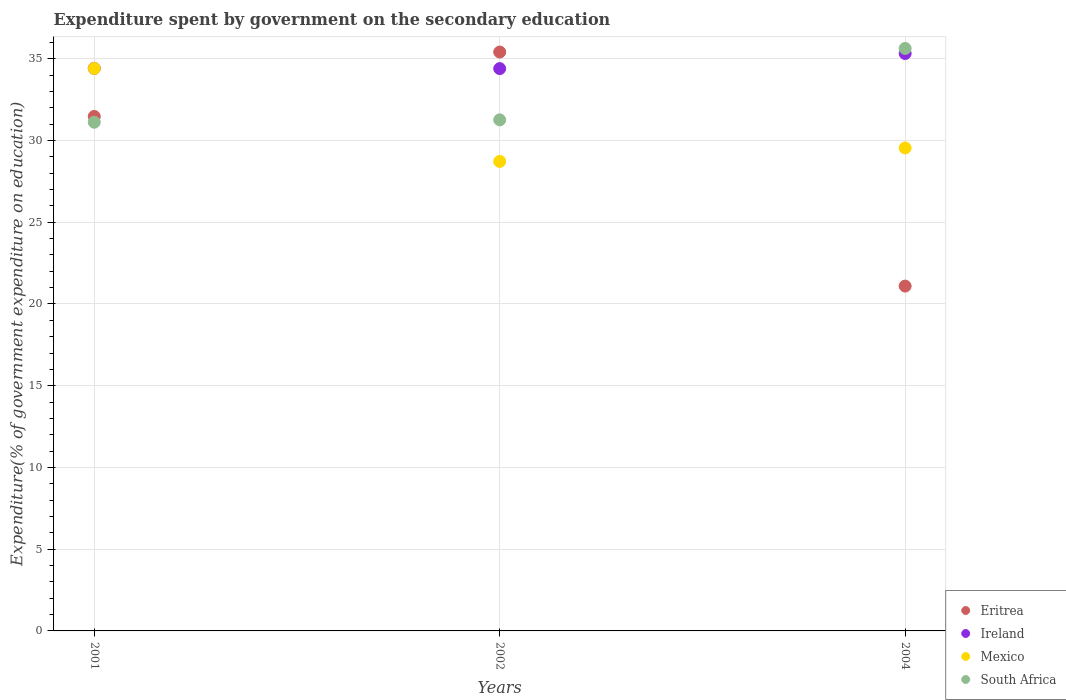What is the expenditure spent by government on the secondary education in Ireland in 2001?
Your answer should be compact. 34.41. Across all years, what is the maximum expenditure spent by government on the secondary education in Ireland?
Offer a very short reply. 35.32. Across all years, what is the minimum expenditure spent by government on the secondary education in Mexico?
Provide a short and direct response. 28.72. In which year was the expenditure spent by government on the secondary education in South Africa maximum?
Your answer should be compact. 2004. What is the total expenditure spent by government on the secondary education in Ireland in the graph?
Give a very brief answer. 104.13. What is the difference between the expenditure spent by government on the secondary education in South Africa in 2001 and that in 2004?
Keep it short and to the point. -4.51. What is the difference between the expenditure spent by government on the secondary education in Mexico in 2002 and the expenditure spent by government on the secondary education in South Africa in 2001?
Give a very brief answer. -2.4. What is the average expenditure spent by government on the secondary education in South Africa per year?
Keep it short and to the point. 32.67. In the year 2002, what is the difference between the expenditure spent by government on the secondary education in Ireland and expenditure spent by government on the secondary education in Eritrea?
Offer a terse response. -1.02. What is the ratio of the expenditure spent by government on the secondary education in Eritrea in 2001 to that in 2002?
Offer a terse response. 0.89. Is the difference between the expenditure spent by government on the secondary education in Ireland in 2001 and 2004 greater than the difference between the expenditure spent by government on the secondary education in Eritrea in 2001 and 2004?
Keep it short and to the point. No. What is the difference between the highest and the second highest expenditure spent by government on the secondary education in Eritrea?
Your answer should be compact. 3.94. What is the difference between the highest and the lowest expenditure spent by government on the secondary education in South Africa?
Offer a very short reply. 4.51. In how many years, is the expenditure spent by government on the secondary education in Mexico greater than the average expenditure spent by government on the secondary education in Mexico taken over all years?
Offer a terse response. 1. Is it the case that in every year, the sum of the expenditure spent by government on the secondary education in Ireland and expenditure spent by government on the secondary education in Eritrea  is greater than the sum of expenditure spent by government on the secondary education in Mexico and expenditure spent by government on the secondary education in South Africa?
Your answer should be compact. Yes. Is the expenditure spent by government on the secondary education in Mexico strictly greater than the expenditure spent by government on the secondary education in Ireland over the years?
Give a very brief answer. No. How many dotlines are there?
Your response must be concise. 4. How many years are there in the graph?
Provide a short and direct response. 3. Are the values on the major ticks of Y-axis written in scientific E-notation?
Make the answer very short. No. Where does the legend appear in the graph?
Your answer should be compact. Bottom right. How many legend labels are there?
Keep it short and to the point. 4. How are the legend labels stacked?
Your response must be concise. Vertical. What is the title of the graph?
Make the answer very short. Expenditure spent by government on the secondary education. Does "Aruba" appear as one of the legend labels in the graph?
Make the answer very short. No. What is the label or title of the X-axis?
Keep it short and to the point. Years. What is the label or title of the Y-axis?
Your answer should be compact. Expenditure(% of government expenditure on education). What is the Expenditure(% of government expenditure on education) in Eritrea in 2001?
Make the answer very short. 31.47. What is the Expenditure(% of government expenditure on education) in Ireland in 2001?
Your response must be concise. 34.41. What is the Expenditure(% of government expenditure on education) in Mexico in 2001?
Your response must be concise. 34.41. What is the Expenditure(% of government expenditure on education) in South Africa in 2001?
Your answer should be very brief. 31.12. What is the Expenditure(% of government expenditure on education) of Eritrea in 2002?
Keep it short and to the point. 35.41. What is the Expenditure(% of government expenditure on education) of Ireland in 2002?
Provide a succinct answer. 34.4. What is the Expenditure(% of government expenditure on education) of Mexico in 2002?
Ensure brevity in your answer.  28.72. What is the Expenditure(% of government expenditure on education) in South Africa in 2002?
Your response must be concise. 31.26. What is the Expenditure(% of government expenditure on education) of Eritrea in 2004?
Give a very brief answer. 21.09. What is the Expenditure(% of government expenditure on education) in Ireland in 2004?
Offer a terse response. 35.32. What is the Expenditure(% of government expenditure on education) in Mexico in 2004?
Offer a very short reply. 29.54. What is the Expenditure(% of government expenditure on education) of South Africa in 2004?
Your answer should be very brief. 35.63. Across all years, what is the maximum Expenditure(% of government expenditure on education) in Eritrea?
Your answer should be compact. 35.41. Across all years, what is the maximum Expenditure(% of government expenditure on education) in Ireland?
Your response must be concise. 35.32. Across all years, what is the maximum Expenditure(% of government expenditure on education) of Mexico?
Keep it short and to the point. 34.41. Across all years, what is the maximum Expenditure(% of government expenditure on education) in South Africa?
Offer a very short reply. 35.63. Across all years, what is the minimum Expenditure(% of government expenditure on education) of Eritrea?
Ensure brevity in your answer.  21.09. Across all years, what is the minimum Expenditure(% of government expenditure on education) of Ireland?
Make the answer very short. 34.4. Across all years, what is the minimum Expenditure(% of government expenditure on education) in Mexico?
Give a very brief answer. 28.72. Across all years, what is the minimum Expenditure(% of government expenditure on education) of South Africa?
Offer a very short reply. 31.12. What is the total Expenditure(% of government expenditure on education) in Eritrea in the graph?
Offer a terse response. 87.98. What is the total Expenditure(% of government expenditure on education) in Ireland in the graph?
Your answer should be very brief. 104.13. What is the total Expenditure(% of government expenditure on education) in Mexico in the graph?
Make the answer very short. 92.67. What is the total Expenditure(% of government expenditure on education) in South Africa in the graph?
Keep it short and to the point. 98.01. What is the difference between the Expenditure(% of government expenditure on education) of Eritrea in 2001 and that in 2002?
Offer a terse response. -3.94. What is the difference between the Expenditure(% of government expenditure on education) of Ireland in 2001 and that in 2002?
Provide a succinct answer. 0.02. What is the difference between the Expenditure(% of government expenditure on education) in Mexico in 2001 and that in 2002?
Your answer should be compact. 5.69. What is the difference between the Expenditure(% of government expenditure on education) in South Africa in 2001 and that in 2002?
Make the answer very short. -0.15. What is the difference between the Expenditure(% of government expenditure on education) in Eritrea in 2001 and that in 2004?
Provide a short and direct response. 10.38. What is the difference between the Expenditure(% of government expenditure on education) in Ireland in 2001 and that in 2004?
Offer a very short reply. -0.91. What is the difference between the Expenditure(% of government expenditure on education) of Mexico in 2001 and that in 2004?
Ensure brevity in your answer.  4.86. What is the difference between the Expenditure(% of government expenditure on education) of South Africa in 2001 and that in 2004?
Give a very brief answer. -4.51. What is the difference between the Expenditure(% of government expenditure on education) of Eritrea in 2002 and that in 2004?
Give a very brief answer. 14.32. What is the difference between the Expenditure(% of government expenditure on education) in Ireland in 2002 and that in 2004?
Your answer should be very brief. -0.92. What is the difference between the Expenditure(% of government expenditure on education) of Mexico in 2002 and that in 2004?
Offer a terse response. -0.82. What is the difference between the Expenditure(% of government expenditure on education) in South Africa in 2002 and that in 2004?
Provide a succinct answer. -4.37. What is the difference between the Expenditure(% of government expenditure on education) in Eritrea in 2001 and the Expenditure(% of government expenditure on education) in Ireland in 2002?
Offer a very short reply. -2.92. What is the difference between the Expenditure(% of government expenditure on education) of Eritrea in 2001 and the Expenditure(% of government expenditure on education) of Mexico in 2002?
Make the answer very short. 2.75. What is the difference between the Expenditure(% of government expenditure on education) of Eritrea in 2001 and the Expenditure(% of government expenditure on education) of South Africa in 2002?
Give a very brief answer. 0.21. What is the difference between the Expenditure(% of government expenditure on education) in Ireland in 2001 and the Expenditure(% of government expenditure on education) in Mexico in 2002?
Provide a succinct answer. 5.69. What is the difference between the Expenditure(% of government expenditure on education) of Ireland in 2001 and the Expenditure(% of government expenditure on education) of South Africa in 2002?
Offer a terse response. 3.15. What is the difference between the Expenditure(% of government expenditure on education) of Mexico in 2001 and the Expenditure(% of government expenditure on education) of South Africa in 2002?
Make the answer very short. 3.14. What is the difference between the Expenditure(% of government expenditure on education) of Eritrea in 2001 and the Expenditure(% of government expenditure on education) of Ireland in 2004?
Offer a terse response. -3.85. What is the difference between the Expenditure(% of government expenditure on education) in Eritrea in 2001 and the Expenditure(% of government expenditure on education) in Mexico in 2004?
Make the answer very short. 1.93. What is the difference between the Expenditure(% of government expenditure on education) of Eritrea in 2001 and the Expenditure(% of government expenditure on education) of South Africa in 2004?
Your answer should be compact. -4.16. What is the difference between the Expenditure(% of government expenditure on education) in Ireland in 2001 and the Expenditure(% of government expenditure on education) in Mexico in 2004?
Provide a succinct answer. 4.87. What is the difference between the Expenditure(% of government expenditure on education) in Ireland in 2001 and the Expenditure(% of government expenditure on education) in South Africa in 2004?
Your answer should be compact. -1.22. What is the difference between the Expenditure(% of government expenditure on education) of Mexico in 2001 and the Expenditure(% of government expenditure on education) of South Africa in 2004?
Keep it short and to the point. -1.22. What is the difference between the Expenditure(% of government expenditure on education) in Eritrea in 2002 and the Expenditure(% of government expenditure on education) in Ireland in 2004?
Your answer should be compact. 0.09. What is the difference between the Expenditure(% of government expenditure on education) in Eritrea in 2002 and the Expenditure(% of government expenditure on education) in Mexico in 2004?
Provide a succinct answer. 5.87. What is the difference between the Expenditure(% of government expenditure on education) of Eritrea in 2002 and the Expenditure(% of government expenditure on education) of South Africa in 2004?
Offer a very short reply. -0.22. What is the difference between the Expenditure(% of government expenditure on education) of Ireland in 2002 and the Expenditure(% of government expenditure on education) of Mexico in 2004?
Provide a short and direct response. 4.85. What is the difference between the Expenditure(% of government expenditure on education) of Ireland in 2002 and the Expenditure(% of government expenditure on education) of South Africa in 2004?
Give a very brief answer. -1.23. What is the difference between the Expenditure(% of government expenditure on education) in Mexico in 2002 and the Expenditure(% of government expenditure on education) in South Africa in 2004?
Your response must be concise. -6.91. What is the average Expenditure(% of government expenditure on education) of Eritrea per year?
Your response must be concise. 29.33. What is the average Expenditure(% of government expenditure on education) in Ireland per year?
Make the answer very short. 34.71. What is the average Expenditure(% of government expenditure on education) of Mexico per year?
Make the answer very short. 30.89. What is the average Expenditure(% of government expenditure on education) in South Africa per year?
Your response must be concise. 32.67. In the year 2001, what is the difference between the Expenditure(% of government expenditure on education) of Eritrea and Expenditure(% of government expenditure on education) of Ireland?
Make the answer very short. -2.94. In the year 2001, what is the difference between the Expenditure(% of government expenditure on education) in Eritrea and Expenditure(% of government expenditure on education) in Mexico?
Keep it short and to the point. -2.94. In the year 2001, what is the difference between the Expenditure(% of government expenditure on education) of Eritrea and Expenditure(% of government expenditure on education) of South Africa?
Ensure brevity in your answer.  0.35. In the year 2001, what is the difference between the Expenditure(% of government expenditure on education) of Ireland and Expenditure(% of government expenditure on education) of Mexico?
Provide a succinct answer. 0.01. In the year 2001, what is the difference between the Expenditure(% of government expenditure on education) of Ireland and Expenditure(% of government expenditure on education) of South Africa?
Offer a very short reply. 3.29. In the year 2001, what is the difference between the Expenditure(% of government expenditure on education) of Mexico and Expenditure(% of government expenditure on education) of South Africa?
Ensure brevity in your answer.  3.29. In the year 2002, what is the difference between the Expenditure(% of government expenditure on education) in Eritrea and Expenditure(% of government expenditure on education) in Ireland?
Make the answer very short. 1.02. In the year 2002, what is the difference between the Expenditure(% of government expenditure on education) in Eritrea and Expenditure(% of government expenditure on education) in Mexico?
Make the answer very short. 6.69. In the year 2002, what is the difference between the Expenditure(% of government expenditure on education) of Eritrea and Expenditure(% of government expenditure on education) of South Africa?
Offer a very short reply. 4.15. In the year 2002, what is the difference between the Expenditure(% of government expenditure on education) of Ireland and Expenditure(% of government expenditure on education) of Mexico?
Keep it short and to the point. 5.68. In the year 2002, what is the difference between the Expenditure(% of government expenditure on education) of Ireland and Expenditure(% of government expenditure on education) of South Africa?
Offer a very short reply. 3.13. In the year 2002, what is the difference between the Expenditure(% of government expenditure on education) of Mexico and Expenditure(% of government expenditure on education) of South Africa?
Keep it short and to the point. -2.54. In the year 2004, what is the difference between the Expenditure(% of government expenditure on education) in Eritrea and Expenditure(% of government expenditure on education) in Ireland?
Your answer should be very brief. -14.23. In the year 2004, what is the difference between the Expenditure(% of government expenditure on education) of Eritrea and Expenditure(% of government expenditure on education) of Mexico?
Offer a very short reply. -8.45. In the year 2004, what is the difference between the Expenditure(% of government expenditure on education) in Eritrea and Expenditure(% of government expenditure on education) in South Africa?
Offer a terse response. -14.54. In the year 2004, what is the difference between the Expenditure(% of government expenditure on education) in Ireland and Expenditure(% of government expenditure on education) in Mexico?
Provide a succinct answer. 5.78. In the year 2004, what is the difference between the Expenditure(% of government expenditure on education) in Ireland and Expenditure(% of government expenditure on education) in South Africa?
Offer a very short reply. -0.31. In the year 2004, what is the difference between the Expenditure(% of government expenditure on education) of Mexico and Expenditure(% of government expenditure on education) of South Africa?
Ensure brevity in your answer.  -6.09. What is the ratio of the Expenditure(% of government expenditure on education) of Eritrea in 2001 to that in 2002?
Your answer should be very brief. 0.89. What is the ratio of the Expenditure(% of government expenditure on education) of Mexico in 2001 to that in 2002?
Provide a succinct answer. 1.2. What is the ratio of the Expenditure(% of government expenditure on education) in South Africa in 2001 to that in 2002?
Keep it short and to the point. 1. What is the ratio of the Expenditure(% of government expenditure on education) of Eritrea in 2001 to that in 2004?
Provide a short and direct response. 1.49. What is the ratio of the Expenditure(% of government expenditure on education) in Ireland in 2001 to that in 2004?
Give a very brief answer. 0.97. What is the ratio of the Expenditure(% of government expenditure on education) of Mexico in 2001 to that in 2004?
Your answer should be compact. 1.16. What is the ratio of the Expenditure(% of government expenditure on education) in South Africa in 2001 to that in 2004?
Provide a short and direct response. 0.87. What is the ratio of the Expenditure(% of government expenditure on education) in Eritrea in 2002 to that in 2004?
Make the answer very short. 1.68. What is the ratio of the Expenditure(% of government expenditure on education) of Ireland in 2002 to that in 2004?
Your answer should be compact. 0.97. What is the ratio of the Expenditure(% of government expenditure on education) in Mexico in 2002 to that in 2004?
Ensure brevity in your answer.  0.97. What is the ratio of the Expenditure(% of government expenditure on education) of South Africa in 2002 to that in 2004?
Offer a very short reply. 0.88. What is the difference between the highest and the second highest Expenditure(% of government expenditure on education) in Eritrea?
Keep it short and to the point. 3.94. What is the difference between the highest and the second highest Expenditure(% of government expenditure on education) of Ireland?
Ensure brevity in your answer.  0.91. What is the difference between the highest and the second highest Expenditure(% of government expenditure on education) of Mexico?
Keep it short and to the point. 4.86. What is the difference between the highest and the second highest Expenditure(% of government expenditure on education) in South Africa?
Offer a terse response. 4.37. What is the difference between the highest and the lowest Expenditure(% of government expenditure on education) in Eritrea?
Offer a terse response. 14.32. What is the difference between the highest and the lowest Expenditure(% of government expenditure on education) of Ireland?
Your response must be concise. 0.92. What is the difference between the highest and the lowest Expenditure(% of government expenditure on education) in Mexico?
Offer a terse response. 5.69. What is the difference between the highest and the lowest Expenditure(% of government expenditure on education) in South Africa?
Give a very brief answer. 4.51. 